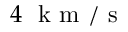<formula> <loc_0><loc_0><loc_500><loc_500>4 k m / s</formula> 